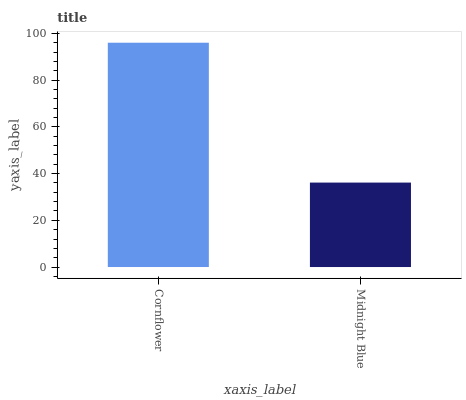Is Midnight Blue the minimum?
Answer yes or no. Yes. Is Cornflower the maximum?
Answer yes or no. Yes. Is Midnight Blue the maximum?
Answer yes or no. No. Is Cornflower greater than Midnight Blue?
Answer yes or no. Yes. Is Midnight Blue less than Cornflower?
Answer yes or no. Yes. Is Midnight Blue greater than Cornflower?
Answer yes or no. No. Is Cornflower less than Midnight Blue?
Answer yes or no. No. Is Cornflower the high median?
Answer yes or no. Yes. Is Midnight Blue the low median?
Answer yes or no. Yes. Is Midnight Blue the high median?
Answer yes or no. No. Is Cornflower the low median?
Answer yes or no. No. 